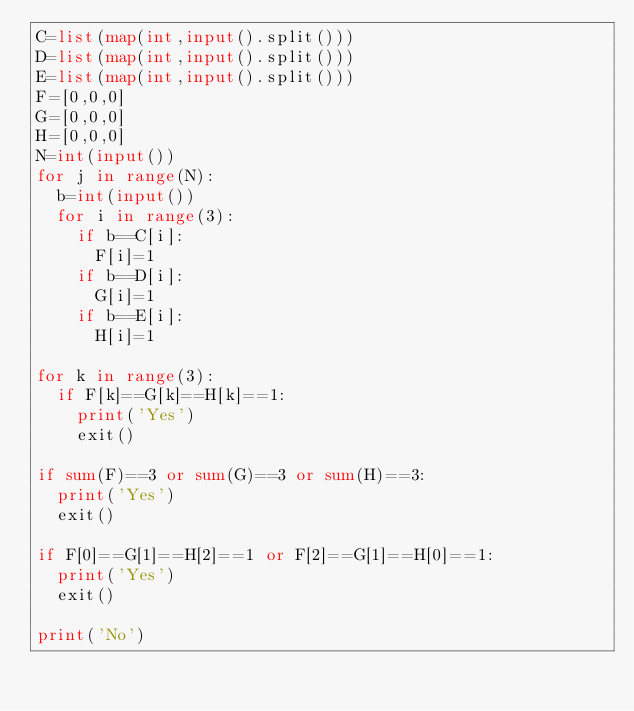Convert code to text. <code><loc_0><loc_0><loc_500><loc_500><_Python_>C=list(map(int,input().split()))
D=list(map(int,input().split()))
E=list(map(int,input().split()))
F=[0,0,0]
G=[0,0,0]
H=[0,0,0]
N=int(input())
for j in range(N):
  b=int(input())
  for i in range(3):
    if b==C[i]:
      F[i]=1
    if b==D[i]:
      G[i]=1
    if b==E[i]:
      H[i]=1
      
for k in range(3):
  if F[k]==G[k]==H[k]==1:
    print('Yes')
    exit()

if sum(F)==3 or sum(G)==3 or sum(H)==3:
  print('Yes')
  exit()

if F[0]==G[1]==H[2]==1 or F[2]==G[1]==H[0]==1:
  print('Yes')
  exit()

print('No')
    
    </code> 